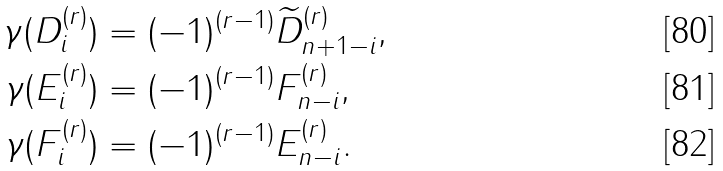<formula> <loc_0><loc_0><loc_500><loc_500>\gamma ( D _ { i } ^ { ( r ) } ) & = ( - 1 ) ^ { ( r - 1 ) } \widetilde { D } _ { n + 1 - i } ^ { ( r ) } , \\ \gamma ( E _ { i } ^ { ( r ) } ) & = ( - 1 ) ^ { ( r - 1 ) } F _ { n - i } ^ { ( r ) } , \\ \gamma ( F _ { i } ^ { ( r ) } ) & = ( - 1 ) ^ { ( r - 1 ) } E _ { n - i } ^ { ( r ) } .</formula> 